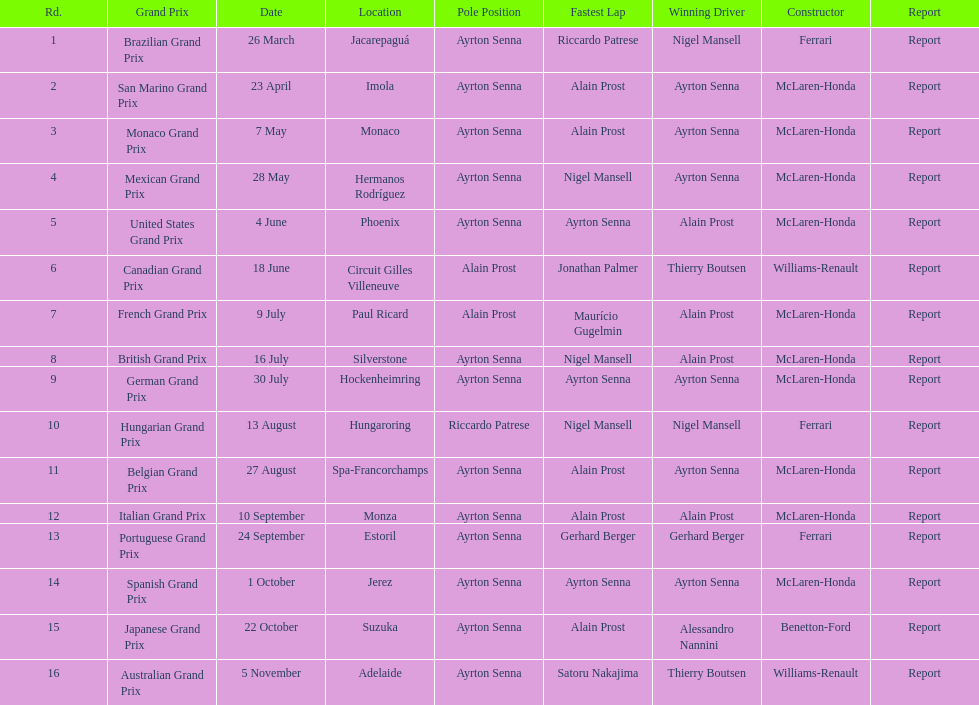Prost claimed the drivers title, who was his colleague? Ayrton Senna. 